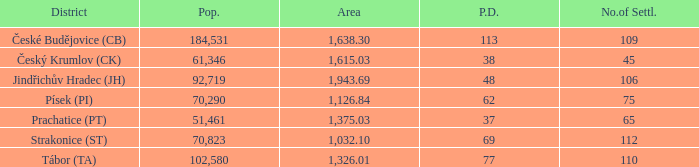What is the population with an area of 1,126.84? 70290.0. 